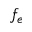Convert formula to latex. <formula><loc_0><loc_0><loc_500><loc_500>f _ { e }</formula> 